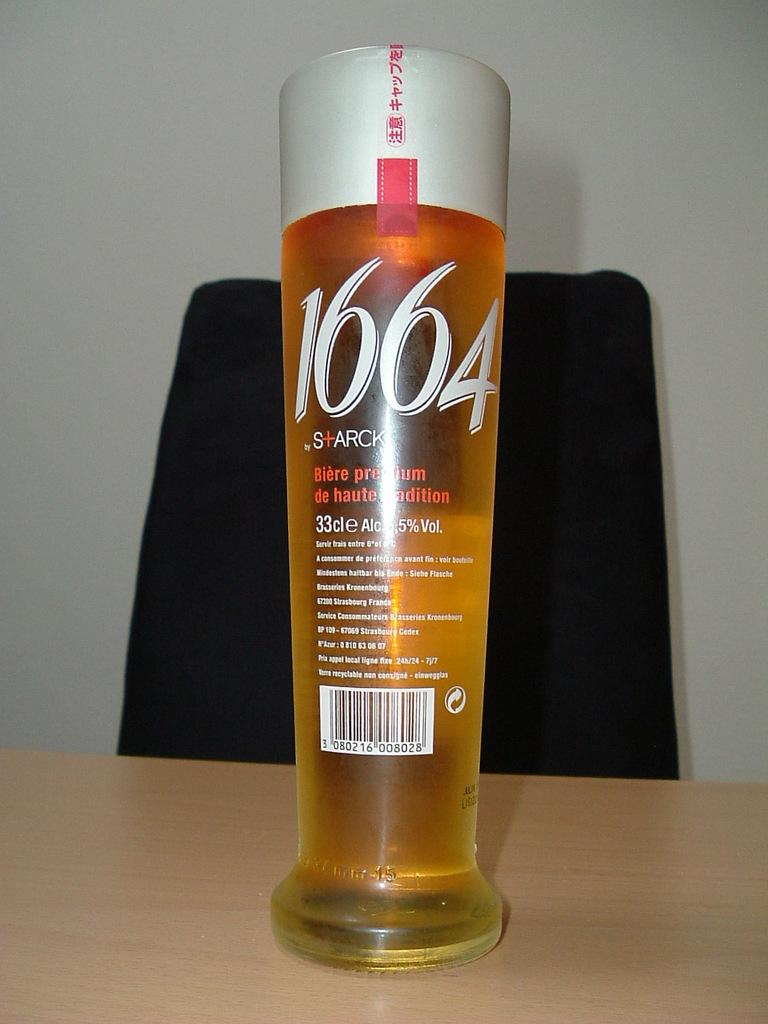What is inside the glass bottle in the image? There is a liquid inside the glass bottle in the image. Where is the glass bottle located? The glass bottle is on a table. What can be seen in the background of the image? There is a chair and a wall in the background of the image. Reasoning: Let's think step by step by step in order to produce the conversation. We start by identifying the main subject in the image, which is the glass bottle with a liquid. Then, we expand the conversation to include the location of the bottle (on a table) and the background elements (a chair and a wall). Each question is designed to elicit a specific detail about the image that is known from the provided facts. Absurd Question/Answer: How many snails are crawling on the wall in the image? There are no snails visible in the image; only a glass bottle, a table, a chair, and a wall are present. How many snails are crawling on the wall in the image? There are no snails visible in the image; only a glass bottle, a table, a chair, and a wall are present. 